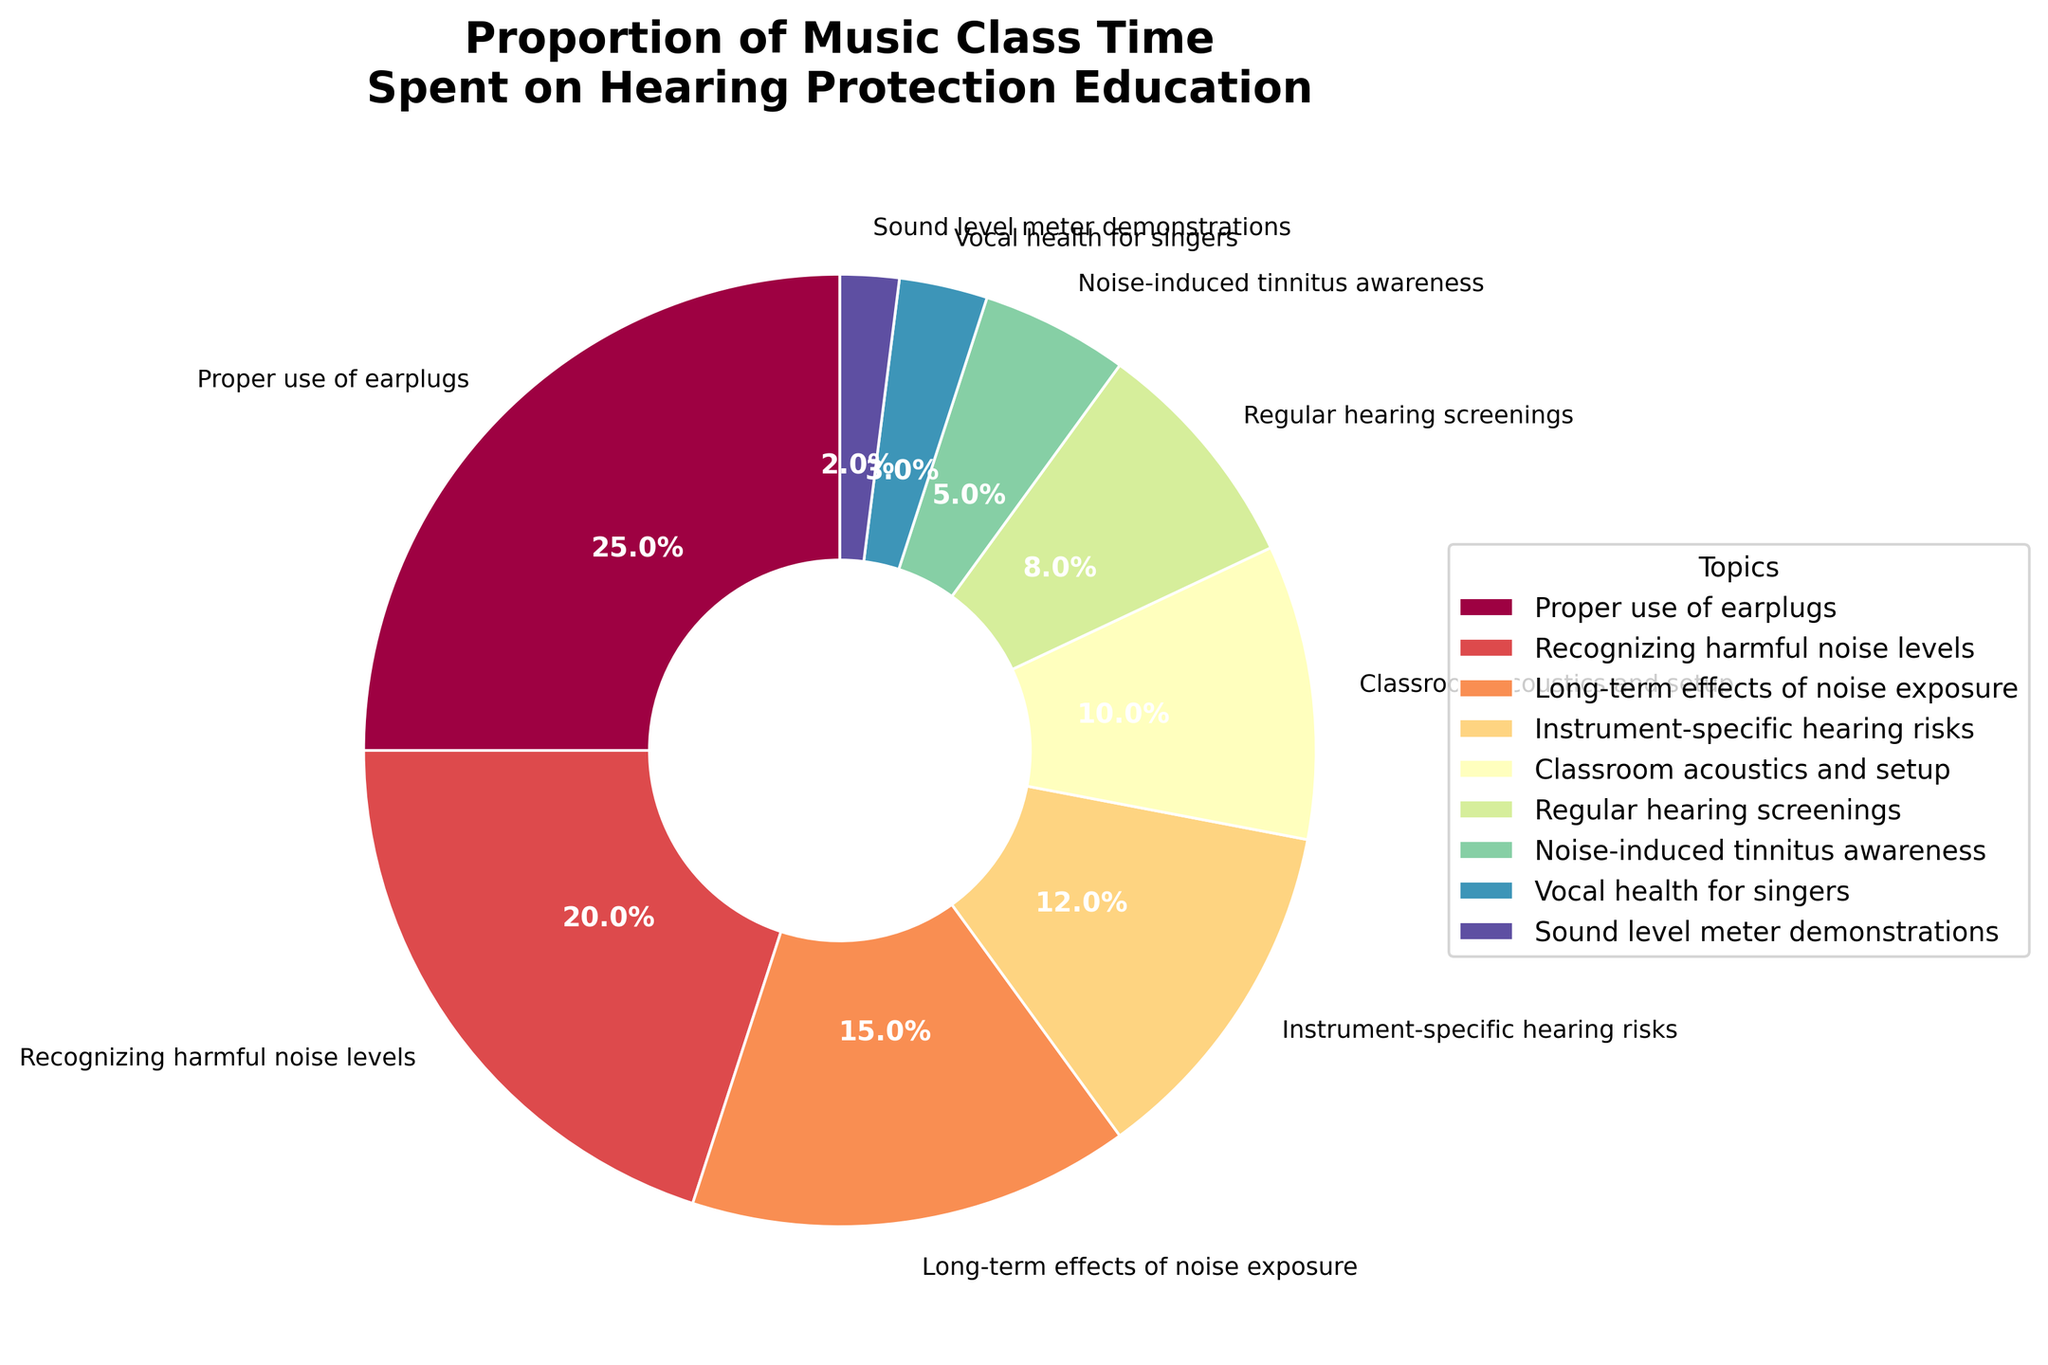Which topic takes up the largest proportion of music class time spent on hearing protection education? The chart shows the largest wedge corresponding to “Proper use of earplugs”, which occupies 25%.
Answer: Proper use of earplugs What is the combined percentage of class time spent on recognizing harmful noise levels and the long-term effects of noise exposure? According to the chart, "Recognizing harmful noise levels" is 20% and "Long-term effects of noise exposure" is 15%. Adding these together gives 20% + 15% = 35%.
Answer: 35% Is the time spent on instrument-specific hearing risks greater or less than the time spent on classroom acoustics and setup? The chart indicates that "Instrument-specific hearing risks" has a percentage of 12%, while "Classroom acoustics and setup" has 10%. Therefore, 12% is greater than 10%.
Answer: Greater What percentage of class time is spent on topics related to general awareness (noise-induced tinnitus awareness, recognizing harmful noise levels, and sound level meter demonstrations)? Adding the percentages for "Noise-induced tinnitus awareness" (5%), "Recognizing harmful noise levels" (20%), and "Sound level meter demonstrations" (2%), we get 5% + 20% + 2% = 27%.
Answer: 27% Which topic occupies the smallest proportion of class time, and what color represents it on the pie chart? The smallest wedge corresponds to "Sound level meter demonstrations" with 2%. This wedge will be assigned one of the colors from the Spectral color map used in the plot.
Answer: Sound level meter demonstrations What is the total percentage of time spent on ear health-related topics (Regular hearing screenings, Noise-induced tinnitus awareness, Proper use of earplugs)? Adding the percentages for "Regular hearing screenings" (8%), "Noise-induced tinnitus awareness" (5%), and "Proper use of earplugs" (25%), we get 8% + 5% + 25% = 38%.
Answer: 38% How much more class time is spent on recognizing harmful noise levels compared to vocal health for singers? According to the chart, "Recognizing harmful noise levels" is 20% and "Vocal health for singers" is 3%. The difference is 20% - 3% = 17%.
Answer: 17% Which two topics together take up almost the same proportion as the time spent on proper use of earplugs? The chart shows that "Recognizing harmful noise levels" is 20% and "Long-term effects of noise exposure" is 15%. Adding these together gives 20% + 15% = 35%, while "Proper use of earplugs" is 25%. Therefore, the pair doesn’t have to be exact, but they should be close; the pair "Recognizing harmful noise levels" and "Regular hearing screenings" (8%) give a closer sum 20% + 8% = 28%.
Answer: Recognizing harmful noise levels, Regular hearing screenings Are there any topics whose combined percentage is equal to the percentage of time spent on instrument-specific hearing risks? If yes, which ones? The chart shows "Instrument-specific hearing risks" is 12%. By checking other combinations: "Classroom acoustics and setup" (10%) + "Vocal health for singers" (3%) = 13%, which isn’t correct. Another combination to check is "Regular hearing screenings" (8%) + "Noise-induced tinnitus awareness" (5%) = 13%, which is also incorrect. Therefore, none of the pairs sum up to 12%.
Answer: No 